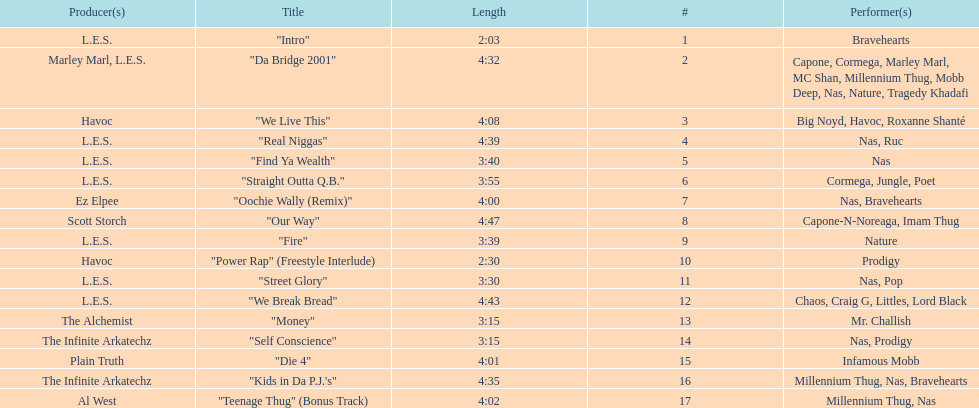What is the duration of the longest track on the list? 4:47. 